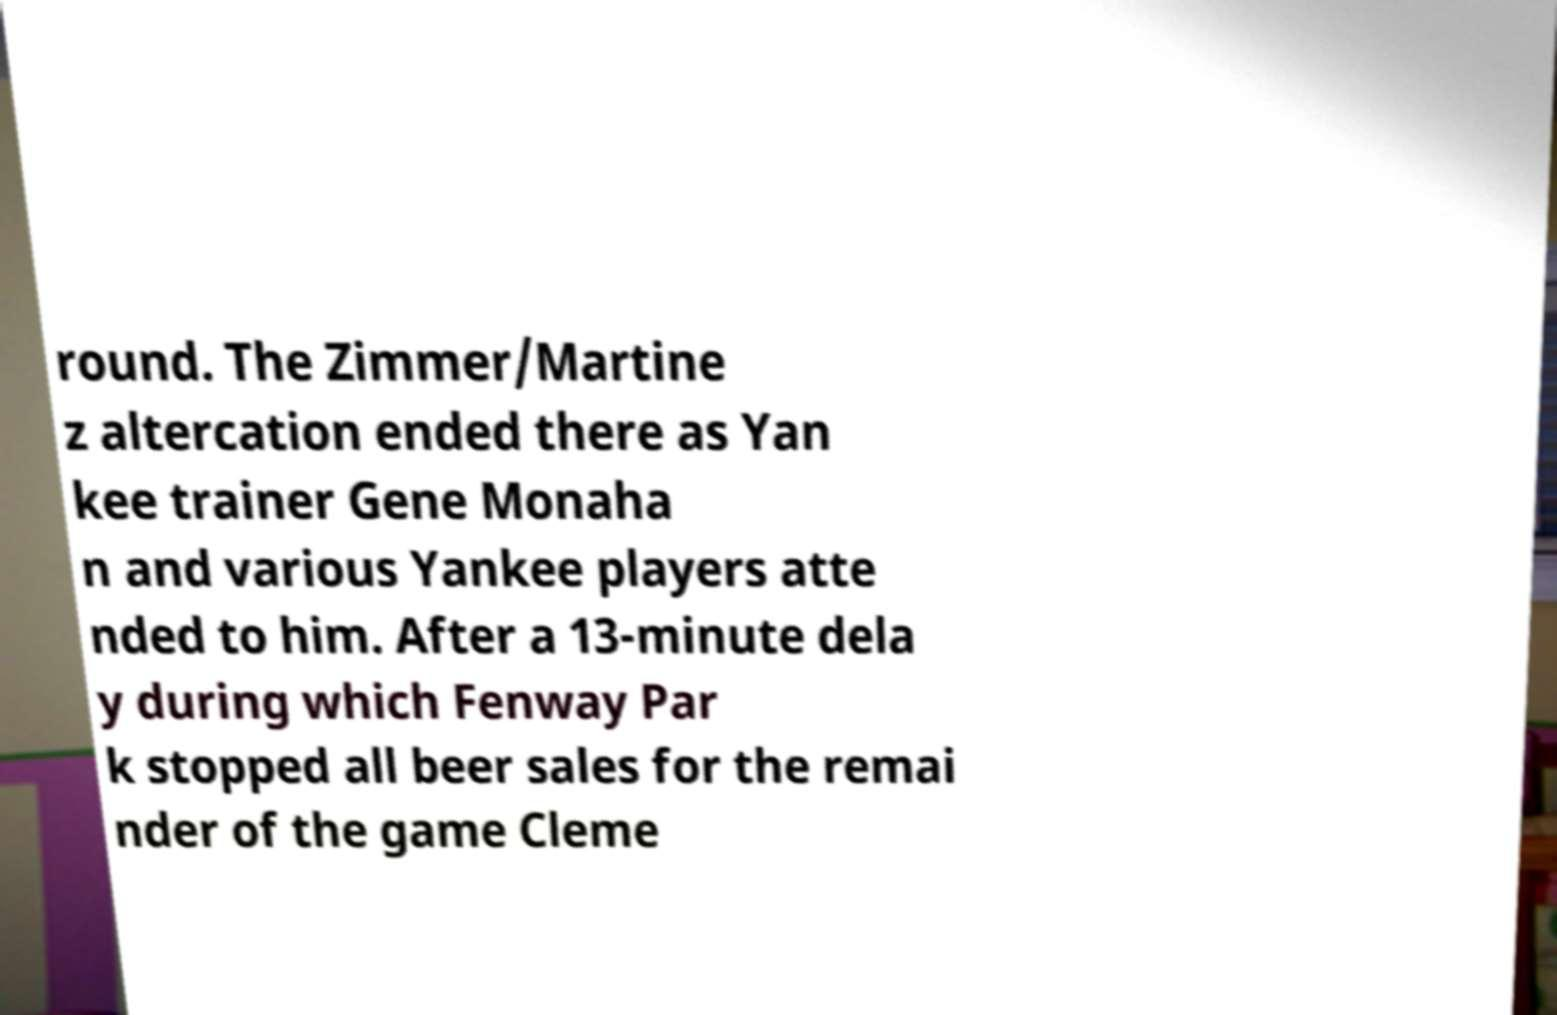Could you assist in decoding the text presented in this image and type it out clearly? round. The Zimmer/Martine z altercation ended there as Yan kee trainer Gene Monaha n and various Yankee players atte nded to him. After a 13-minute dela y during which Fenway Par k stopped all beer sales for the remai nder of the game Cleme 